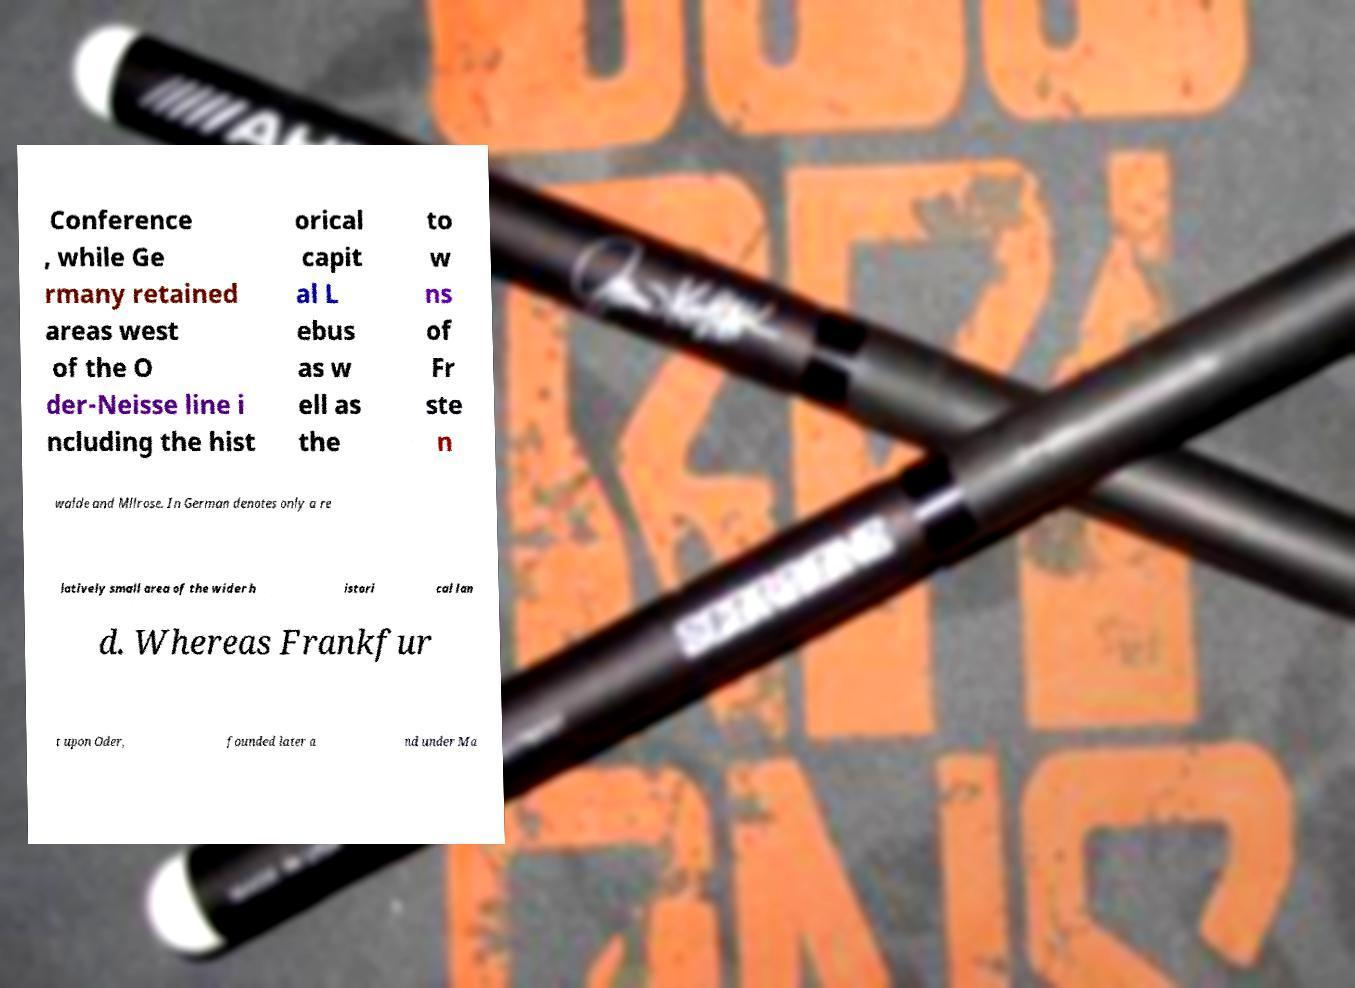There's text embedded in this image that I need extracted. Can you transcribe it verbatim? Conference , while Ge rmany retained areas west of the O der-Neisse line i ncluding the hist orical capit al L ebus as w ell as the to w ns of Fr ste n walde and Mllrose. In German denotes only a re latively small area of the wider h istori cal lan d. Whereas Frankfur t upon Oder, founded later a nd under Ma 